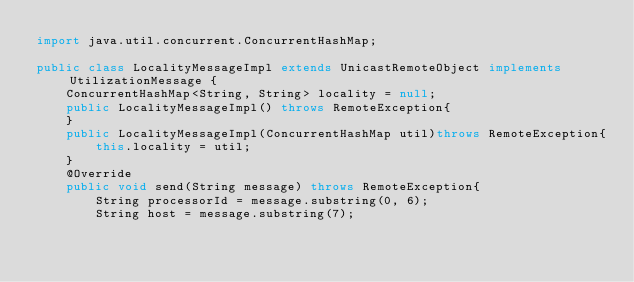Convert code to text. <code><loc_0><loc_0><loc_500><loc_500><_Java_>import java.util.concurrent.ConcurrentHashMap;

public class LocalityMessageImpl extends UnicastRemoteObject implements UtilizationMessage {
    ConcurrentHashMap<String, String> locality = null;
    public LocalityMessageImpl() throws RemoteException{
    }
    public LocalityMessageImpl(ConcurrentHashMap util)throws RemoteException{
        this.locality = util;
    }
    @Override
    public void send(String message) throws RemoteException{
        String processorId = message.substring(0, 6);
        String host = message.substring(7);</code> 